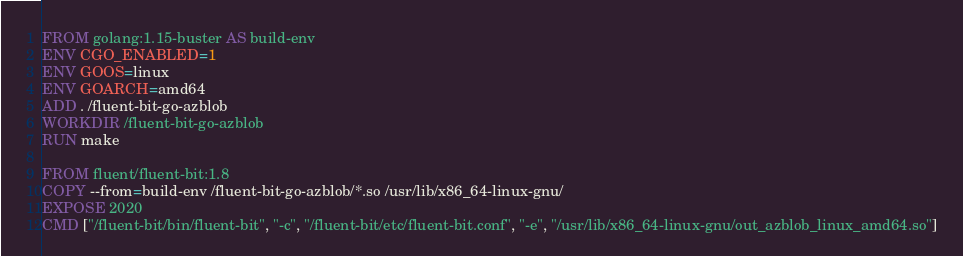Convert code to text. <code><loc_0><loc_0><loc_500><loc_500><_Dockerfile_>FROM golang:1.15-buster AS build-env
ENV CGO_ENABLED=1
ENV GOOS=linux
ENV GOARCH=amd64
ADD . /fluent-bit-go-azblob
WORKDIR /fluent-bit-go-azblob
RUN make

FROM fluent/fluent-bit:1.8
COPY --from=build-env /fluent-bit-go-azblob/*.so /usr/lib/x86_64-linux-gnu/
EXPOSE 2020
CMD ["/fluent-bit/bin/fluent-bit", "-c", "/fluent-bit/etc/fluent-bit.conf", "-e", "/usr/lib/x86_64-linux-gnu/out_azblob_linux_amd64.so"]
</code> 